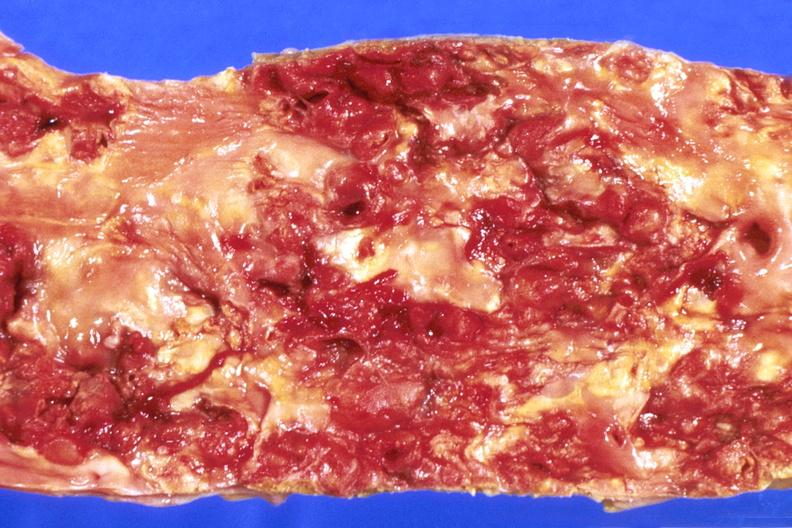does this image show abdominal aorta, severe atherosclerosis?
Answer the question using a single word or phrase. Yes 